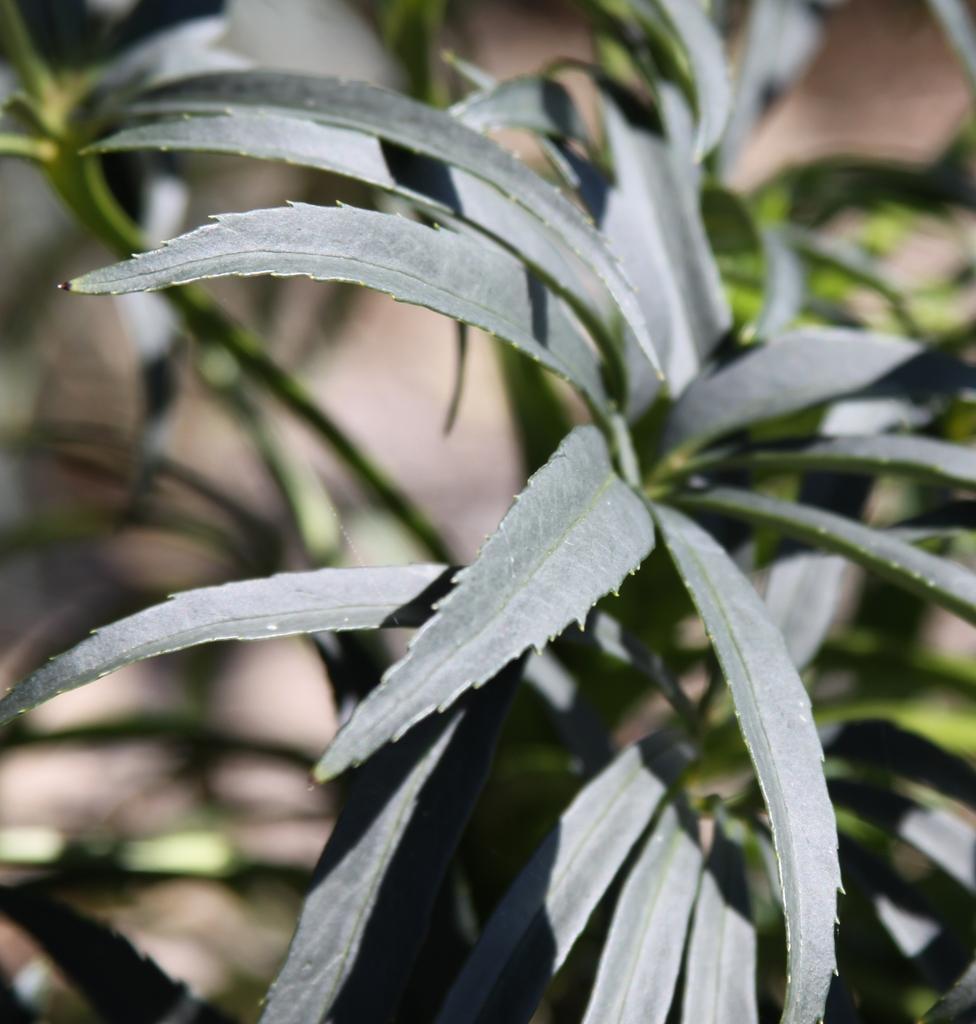How would you summarize this image in a sentence or two? In this image we can see some green plants on the ground and the background is blurred. 